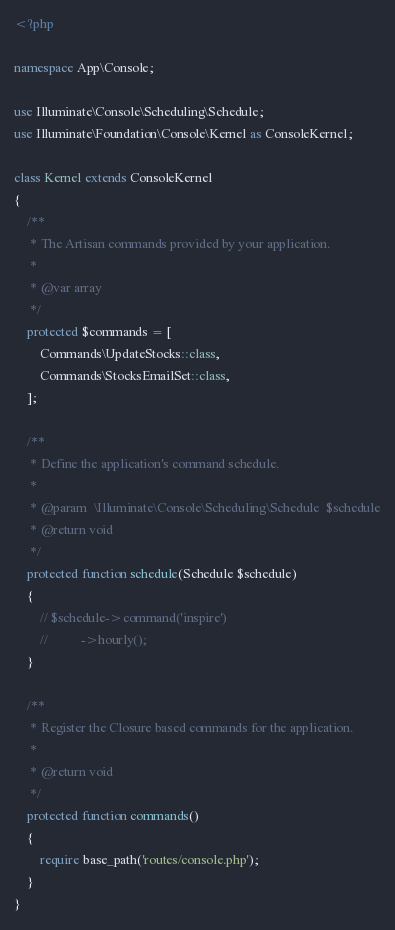<code> <loc_0><loc_0><loc_500><loc_500><_PHP_><?php

namespace App\Console;

use Illuminate\Console\Scheduling\Schedule;
use Illuminate\Foundation\Console\Kernel as ConsoleKernel;

class Kernel extends ConsoleKernel
{
    /**
     * The Artisan commands provided by your application.
     *
     * @var array
     */
    protected $commands = [
        Commands\UpdateStocks::class,
        Commands\StocksEmailSet::class,
    ];

    /**
     * Define the application's command schedule.
     *
     * @param  \Illuminate\Console\Scheduling\Schedule  $schedule
     * @return void
     */
    protected function schedule(Schedule $schedule)
    {
        // $schedule->command('inspire')
        //          ->hourly();
    }

    /**
     * Register the Closure based commands for the application.
     *
     * @return void
     */
    protected function commands()
    {
        require base_path('routes/console.php');
    }
}
</code> 